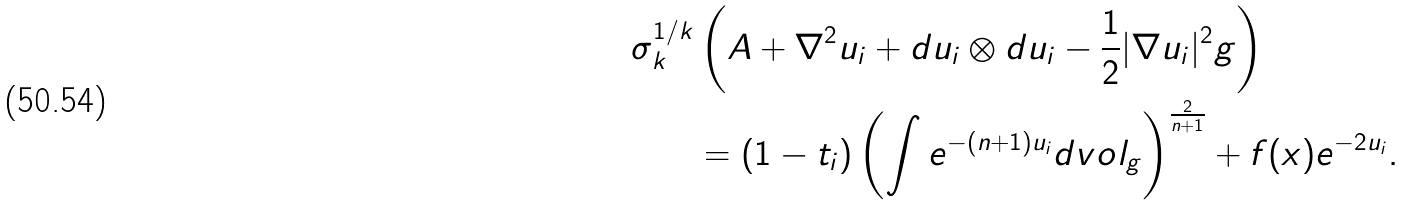<formula> <loc_0><loc_0><loc_500><loc_500>\sigma _ { k } ^ { 1 / k } & \left ( A + \nabla ^ { 2 } u _ { i } + d u _ { i } \otimes d u _ { i } - \frac { 1 } { 2 } | \nabla u _ { i } | ^ { 2 } g \right ) \\ & = ( 1 - t _ { i } ) \left ( \int e ^ { - ( n + 1 ) u _ { i } } d v o l _ { g } \right ) ^ { \frac { 2 } { n + 1 } } + f ( x ) e ^ { - 2 u _ { i } } .</formula> 